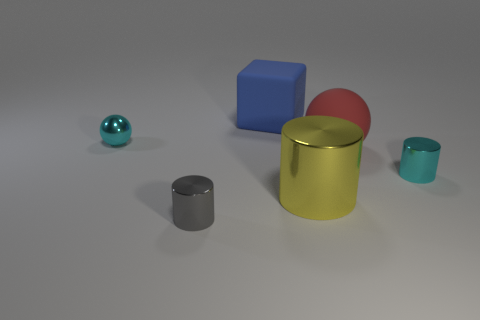There is a large block; how many blue matte objects are to the left of it?
Offer a very short reply. 0. Is the number of small matte cylinders less than the number of tiny cylinders?
Give a very brief answer. Yes. There is a metallic cylinder that is left of the cyan cylinder and to the right of the big blue matte object; what is its size?
Your answer should be compact. Large. Do the metal cylinder that is behind the big shiny cylinder and the tiny ball have the same color?
Keep it short and to the point. Yes. Are there fewer tiny metal balls that are in front of the yellow cylinder than red spheres?
Provide a short and direct response. Yes. What shape is the gray object that is made of the same material as the tiny cyan ball?
Your answer should be compact. Cylinder. Do the large block and the large ball have the same material?
Keep it short and to the point. Yes. Is the number of red things that are behind the big blue matte cube less than the number of large yellow things in front of the small sphere?
Offer a terse response. Yes. There is a metal cylinder that is the same color as the shiny sphere; what size is it?
Offer a terse response. Small. How many large matte things are behind the small shiny thing behind the tiny cyan thing in front of the big red thing?
Your answer should be compact. 1. 